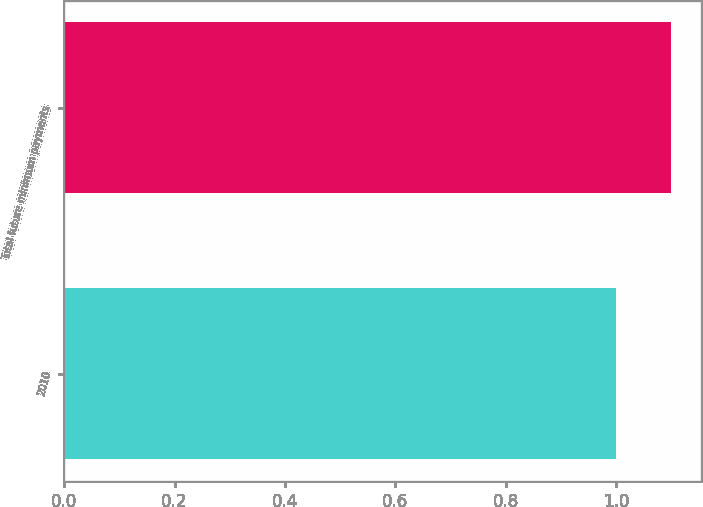<chart> <loc_0><loc_0><loc_500><loc_500><bar_chart><fcel>2010<fcel>Total future minimum payments<nl><fcel>1<fcel>1.1<nl></chart> 